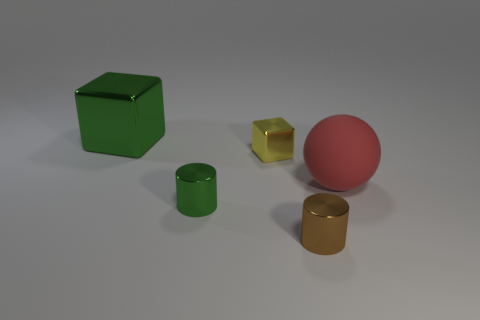There is a big thing to the left of the green metallic object in front of the large object to the left of the red ball; what is it made of?
Offer a very short reply. Metal. There is a green object that is on the right side of the large block; is it the same size as the green shiny object behind the red ball?
Offer a very short reply. No. How many other objects are there of the same material as the yellow object?
Offer a terse response. 3. How many shiny things are either brown objects or cubes?
Provide a short and direct response. 3. Are there fewer big metal things than objects?
Give a very brief answer. Yes. Does the red matte object have the same size as the green object that is in front of the red matte thing?
Your answer should be compact. No. Is there anything else that has the same shape as the tiny green object?
Ensure brevity in your answer.  Yes. What is the size of the rubber thing?
Give a very brief answer. Large. Is the number of tiny shiny objects that are to the right of the red rubber object less than the number of brown things?
Make the answer very short. Yes. Is the size of the green metal cylinder the same as the rubber object?
Give a very brief answer. No. 